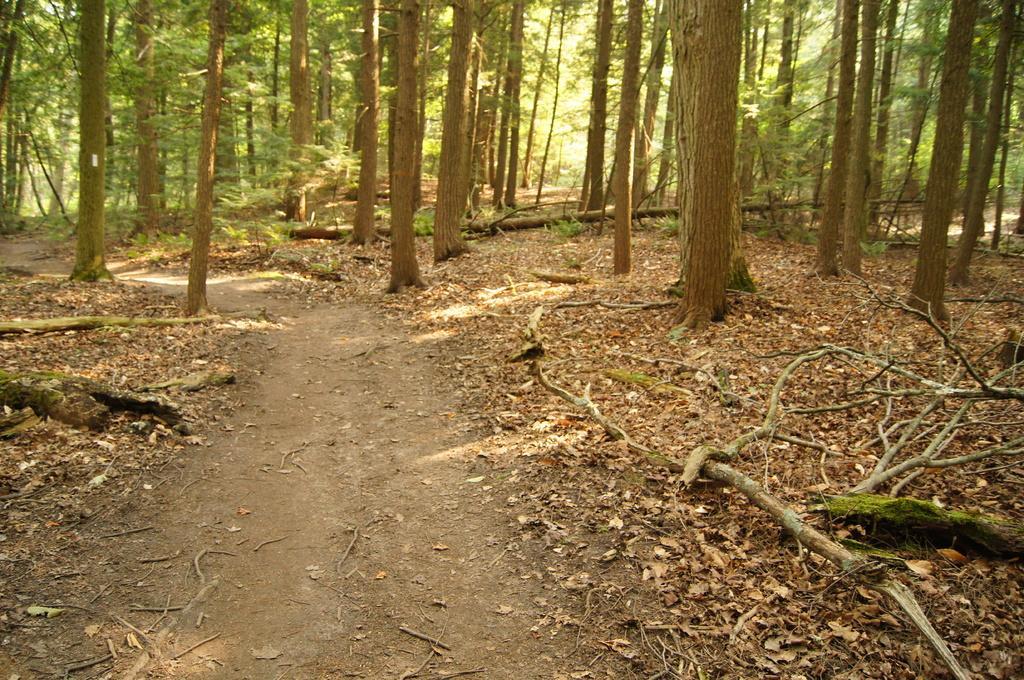Can you describe this image briefly? In the picture we can see a forest area with a path and some dried leaves on it and behind it we can see many trees. 